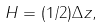Convert formula to latex. <formula><loc_0><loc_0><loc_500><loc_500>H = ( 1 / 2 ) \Delta z ,</formula> 